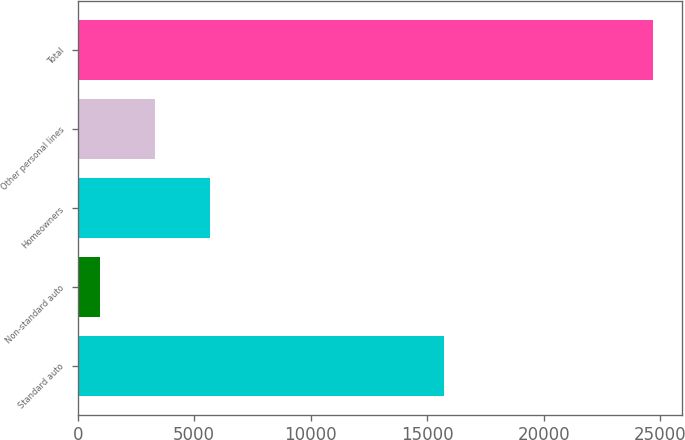Convert chart to OTSL. <chart><loc_0><loc_0><loc_500><loc_500><bar_chart><fcel>Standard auto<fcel>Non-standard auto<fcel>Homeowners<fcel>Other personal lines<fcel>Total<nl><fcel>15735<fcel>939<fcel>5693<fcel>3316<fcel>24709<nl></chart> 